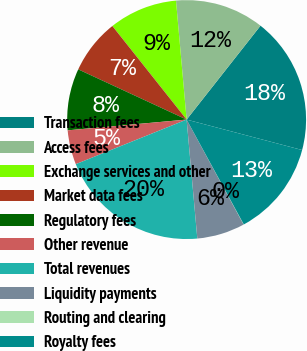Convert chart. <chart><loc_0><loc_0><loc_500><loc_500><pie_chart><fcel>Transaction fees<fcel>Access fees<fcel>Exchange services and other<fcel>Market data fees<fcel>Regulatory fees<fcel>Other revenue<fcel>Total revenues<fcel>Liquidity payments<fcel>Routing and clearing<fcel>Royalty fees<nl><fcel>18.49%<fcel>12.03%<fcel>9.26%<fcel>7.42%<fcel>8.34%<fcel>4.65%<fcel>20.34%<fcel>6.49%<fcel>0.03%<fcel>12.95%<nl></chart> 